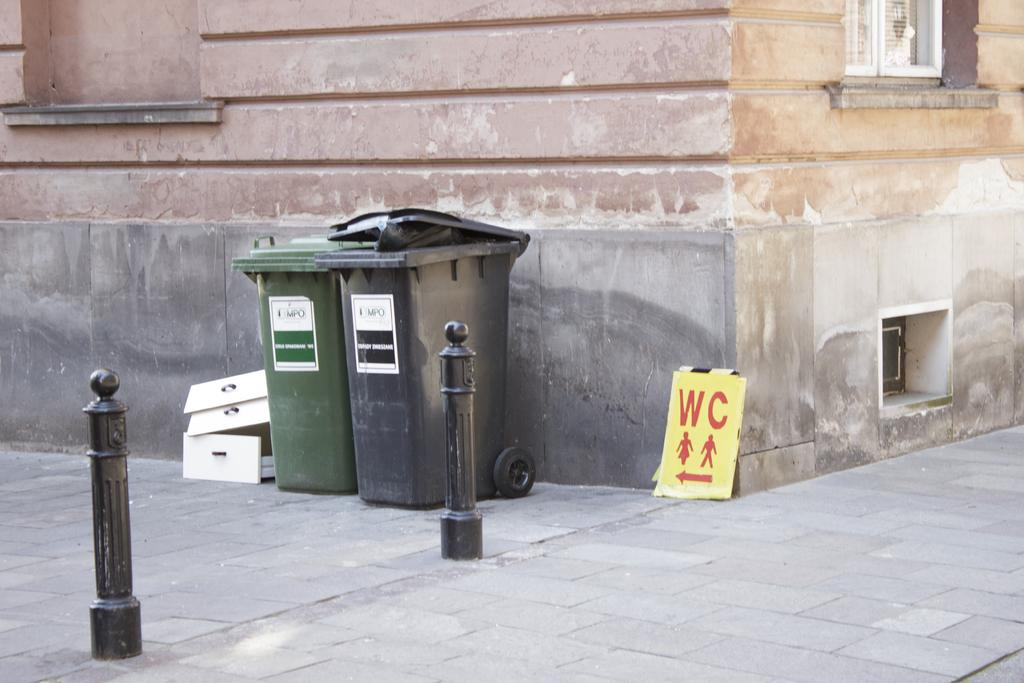<image>
Offer a succinct explanation of the picture presented. A green and a grey trashcan sitting next to each other. 